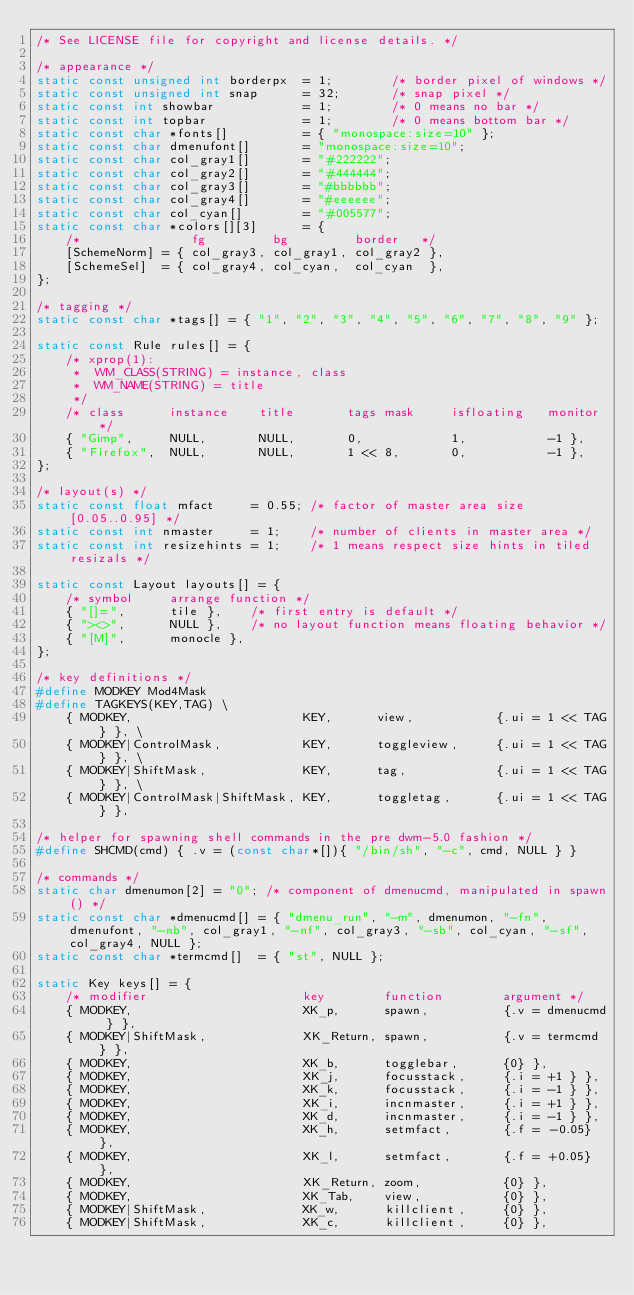Convert code to text. <code><loc_0><loc_0><loc_500><loc_500><_C_>/* See LICENSE file for copyright and license details. */

/* appearance */
static const unsigned int borderpx  = 1;        /* border pixel of windows */
static const unsigned int snap      = 32;       /* snap pixel */
static const int showbar            = 1;        /* 0 means no bar */
static const int topbar             = 1;        /* 0 means bottom bar */
static const char *fonts[]          = { "monospace:size=10" };
static const char dmenufont[]       = "monospace:size=10";
static const char col_gray1[]       = "#222222";
static const char col_gray2[]       = "#444444";
static const char col_gray3[]       = "#bbbbbb";
static const char col_gray4[]       = "#eeeeee";
static const char col_cyan[]        = "#005577";
static const char *colors[][3]      = {
	/*               fg         bg         border   */
	[SchemeNorm] = { col_gray3, col_gray1, col_gray2 },
	[SchemeSel]  = { col_gray4, col_cyan,  col_cyan  },
};

/* tagging */
static const char *tags[] = { "1", "2", "3", "4", "5", "6", "7", "8", "9" };

static const Rule rules[] = {
	/* xprop(1):
	 *	WM_CLASS(STRING) = instance, class
	 *	WM_NAME(STRING) = title
	 */
	/* class      instance    title       tags mask     isfloating   monitor */
	{ "Gimp",     NULL,       NULL,       0,            1,           -1 },
	{ "Firefox",  NULL,       NULL,       1 << 8,       0,           -1 },
};

/* layout(s) */
static const float mfact     = 0.55; /* factor of master area size [0.05..0.95] */
static const int nmaster     = 1;    /* number of clients in master area */
static const int resizehints = 1;    /* 1 means respect size hints in tiled resizals */

static const Layout layouts[] = {
	/* symbol     arrange function */
	{ "[]=",      tile },    /* first entry is default */
	{ "><>",      NULL },    /* no layout function means floating behavior */
	{ "[M]",      monocle },
};

/* key definitions */
#define MODKEY Mod4Mask
#define TAGKEYS(KEY,TAG) \
	{ MODKEY,                       KEY,      view,           {.ui = 1 << TAG} }, \
	{ MODKEY|ControlMask,           KEY,      toggleview,     {.ui = 1 << TAG} }, \
	{ MODKEY|ShiftMask,             KEY,      tag,            {.ui = 1 << TAG} }, \
	{ MODKEY|ControlMask|ShiftMask, KEY,      toggletag,      {.ui = 1 << TAG} },

/* helper for spawning shell commands in the pre dwm-5.0 fashion */
#define SHCMD(cmd) { .v = (const char*[]){ "/bin/sh", "-c", cmd, NULL } }

/* commands */
static char dmenumon[2] = "0"; /* component of dmenucmd, manipulated in spawn() */
static const char *dmenucmd[] = { "dmenu_run", "-m", dmenumon, "-fn", dmenufont, "-nb", col_gray1, "-nf", col_gray3, "-sb", col_cyan, "-sf", col_gray4, NULL };
static const char *termcmd[]  = { "st", NULL };

static Key keys[] = {
	/* modifier                     key        function        argument */
	{ MODKEY,                       XK_p,      spawn,          {.v = dmenucmd } },
	{ MODKEY|ShiftMask,             XK_Return, spawn,          {.v = termcmd } },
	{ MODKEY,                       XK_b,      togglebar,      {0} },
	{ MODKEY,                       XK_j,      focusstack,     {.i = +1 } },
	{ MODKEY,                       XK_k,      focusstack,     {.i = -1 } },
	{ MODKEY,                       XK_i,      incnmaster,     {.i = +1 } },
	{ MODKEY,                       XK_d,      incnmaster,     {.i = -1 } },
	{ MODKEY,                       XK_h,      setmfact,       {.f = -0.05} },
	{ MODKEY,                       XK_l,      setmfact,       {.f = +0.05} },
	{ MODKEY,                       XK_Return, zoom,           {0} },
	{ MODKEY,                       XK_Tab,    view,           {0} },
	{ MODKEY|ShiftMask,             XK_w,      killclient,     {0} },
	{ MODKEY|ShiftMask,             XK_c,      killclient,     {0} },</code> 